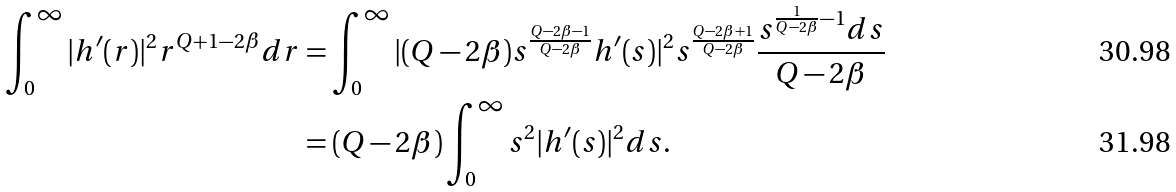Convert formula to latex. <formula><loc_0><loc_0><loc_500><loc_500>\int ^ { \infty } _ { 0 } | h ^ { \prime } ( r ) | ^ { 2 } r ^ { Q + 1 - 2 \beta } d r & = \int ^ { \infty } _ { 0 } | ( Q - 2 \beta ) s ^ { \frac { Q - 2 \beta - 1 } { Q - 2 \beta } } h ^ { \prime } ( s ) | ^ { 2 } s ^ { \frac { Q - 2 \beta + 1 } { Q - 2 \beta } } \frac { s ^ { \frac { 1 } { Q - 2 \beta } - 1 } d s } { Q - 2 \beta } \\ & = ( Q - 2 \beta ) \int ^ { \infty } _ { 0 } s ^ { 2 } | h ^ { \prime } ( s ) | ^ { 2 } d s .</formula> 